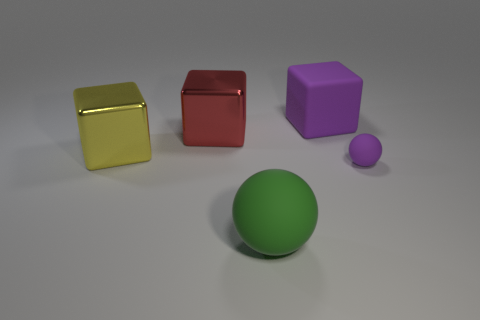Subtract all large shiny blocks. How many blocks are left? 1 Subtract all red cubes. How many cubes are left? 2 Subtract all balls. How many objects are left? 3 Add 2 small red matte things. How many objects exist? 7 Subtract 2 blocks. How many blocks are left? 1 Subtract all spheres. Subtract all large red cubes. How many objects are left? 2 Add 2 small things. How many small things are left? 3 Add 4 big brown metallic spheres. How many big brown metallic spheres exist? 4 Subtract 0 brown spheres. How many objects are left? 5 Subtract all blue balls. Subtract all gray cubes. How many balls are left? 2 